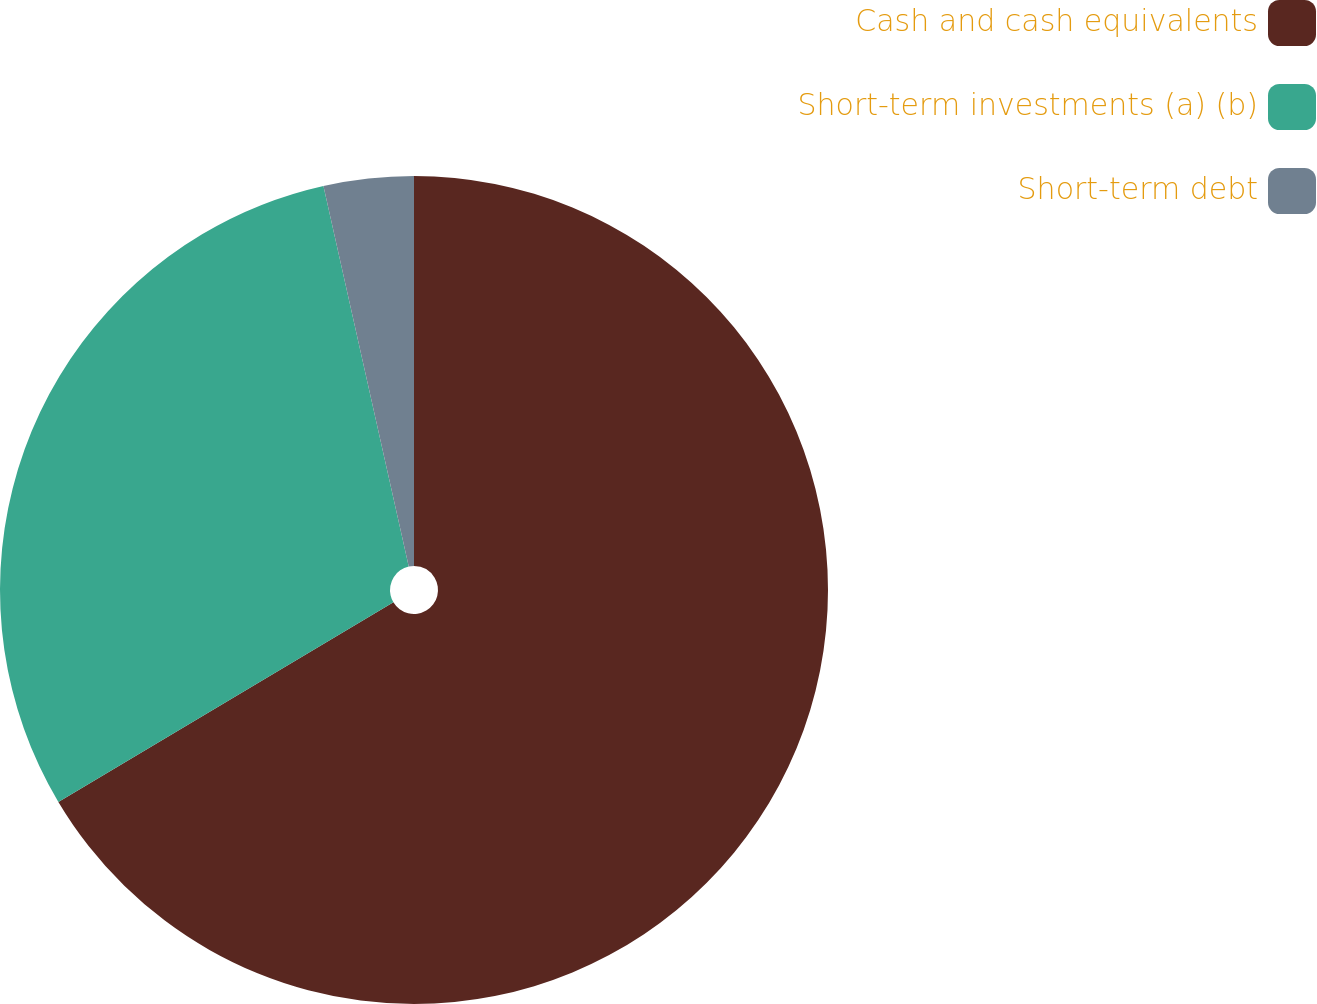Convert chart. <chart><loc_0><loc_0><loc_500><loc_500><pie_chart><fcel>Cash and cash equivalents<fcel>Short-term investments (a) (b)<fcel>Short-term debt<nl><fcel>66.44%<fcel>30.04%<fcel>3.51%<nl></chart> 